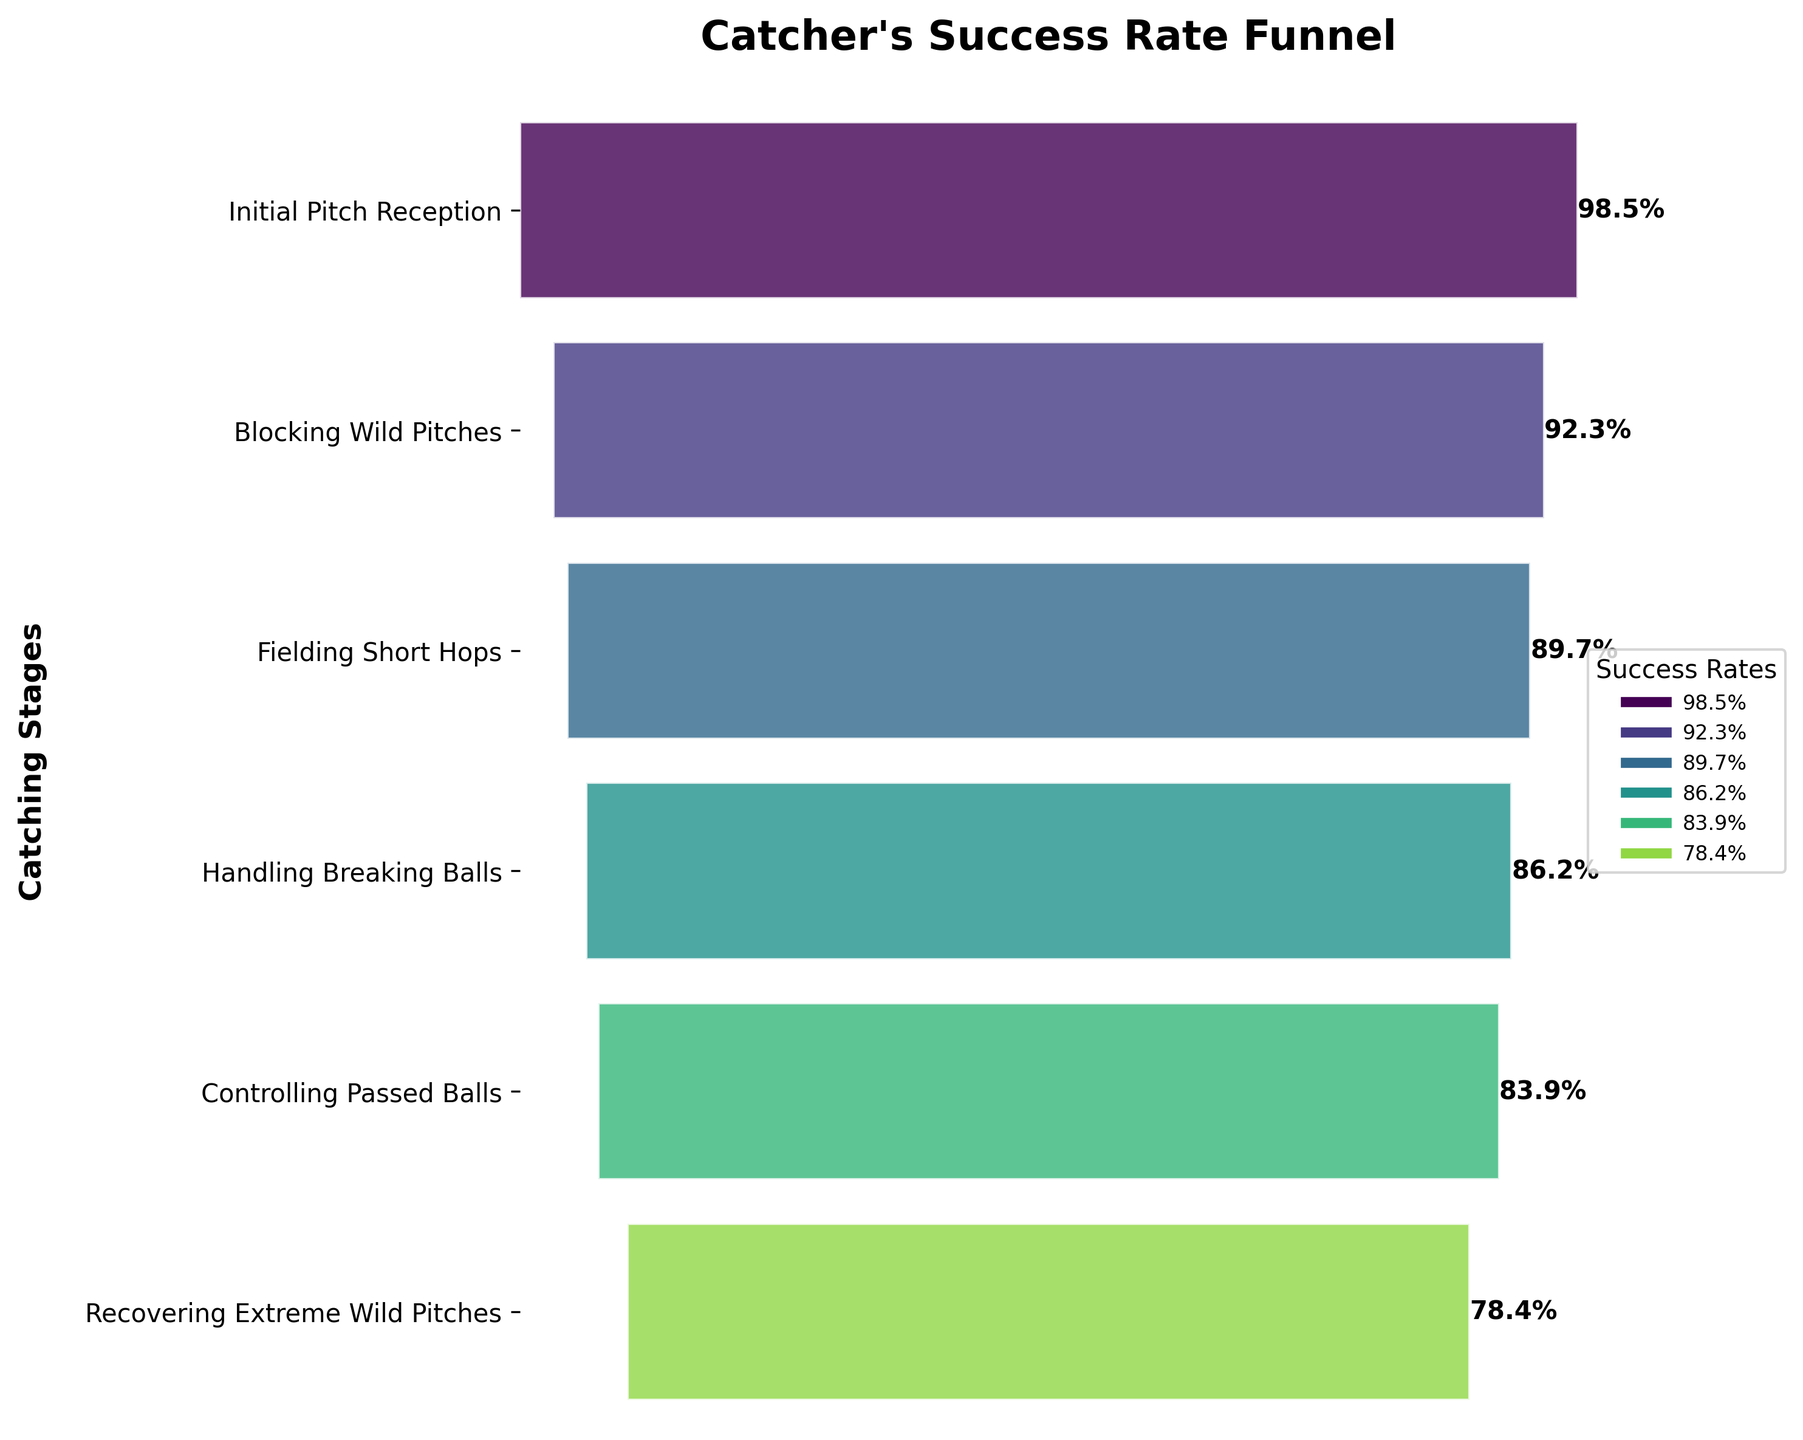Which stage has the highest success rate? The stage with the highest bar segment indicates the highest success rate. In this case, the "Initial Pitch Reception" stage has the highest success rate.
Answer: Initial Pitch Reception What is the success rate for handling breaking balls? Locate the segment labeled "Handling Breaking Balls" and refer to its success rate. The success rate for this stage is shown as 86.2%.
Answer: 86.2% How does the success rate for blocking wild pitches compare to controlling passed balls? Compare the success rates of the stages "Blocking Wild Pitches" and "Controlling Passed Balls". Blocking wild pitches has a success rate of 92.3%, while controlling passed balls has a success rate of 83.9%.
Answer: Blocking wild pitches has a higher success rate What is the approximate reduction in success rate from initial pitch reception to recovering extreme wild pitches? Subtract the success rate of the "Recovering Extreme Wild Pitches" stage from the "Initial Pitch Reception" stage (98.5% - 78.4% = 20.1%).
Answer: 20.1% Which stage has the lowest success rate? The stage with the smallest width in the funnel chart represents the lowest success rate. "Recovering Extreme Wild Pitches" has the lowest success rate.
Answer: Recovering Extreme Wild Pitches Are there any stages with a success rate below 80%? Check each segment to see if any success rates are less than 80%. The "Recovering Extreme Wild Pitches" stage has a success rate of 78.4%, which is below 80%.
Answer: Yes Is the success rate for fielding short hops higher or lower than handling breaking balls? Compare the success rates of the stages "Fielding Short Hops" (89.7%) and "Handling Breaking Balls" (86.2%).
Answer: Higher What is the overall trend observed in the catcher's success rate as they progress through the stages? Observe the slope and decreasing widths of the funnel segments. The success rate decreases as the catcher moves through the stages from initial pitch reception to recovering extreme wild pitches.
Answer: Decreasing By how much does the success rate decrease from blocking wild pitches to handling breaking balls? Subtract the success rate of "Handling Breaking Balls" from the success rate of "Blocking Wild Pitches" (92.3% - 86.2% = 6.1%).
Answer: 6.1% 